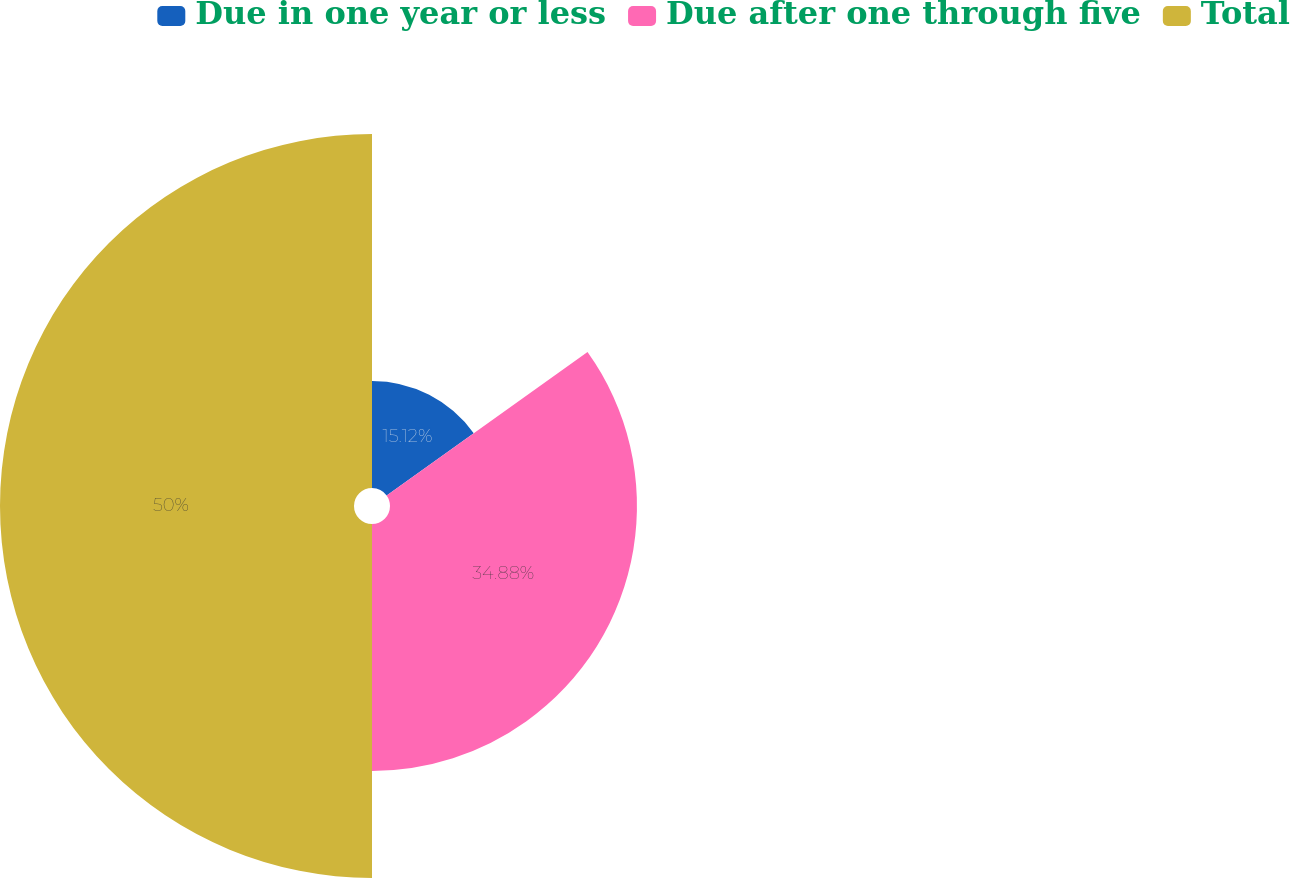<chart> <loc_0><loc_0><loc_500><loc_500><pie_chart><fcel>Due in one year or less<fcel>Due after one through five<fcel>Total<nl><fcel>15.12%<fcel>34.88%<fcel>50.0%<nl></chart> 